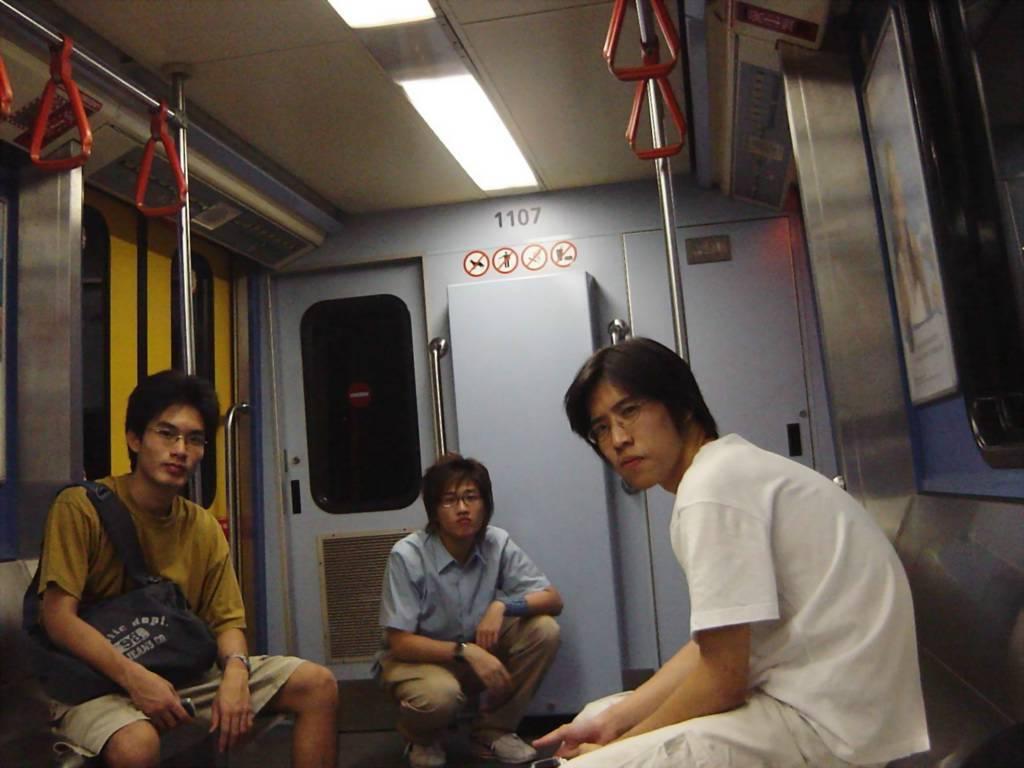Please provide a concise description of this image. In this image I can see the interior of the train in which I can see three persons sitting. I can see few poles, few red colored holders, the ceiling, few lights, a board and few windows. 